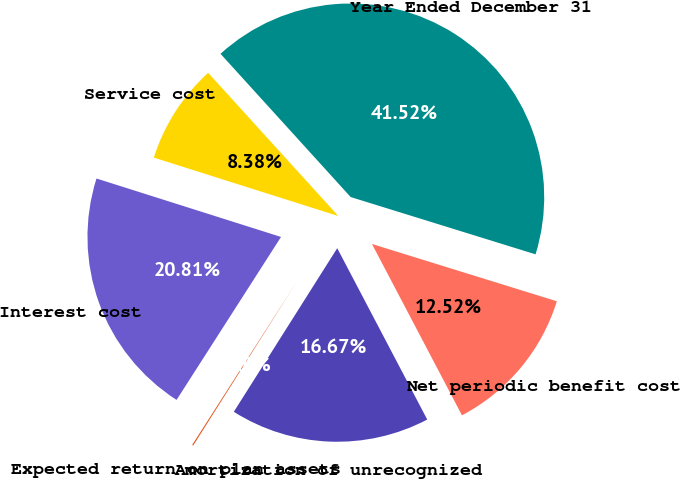Convert chart to OTSL. <chart><loc_0><loc_0><loc_500><loc_500><pie_chart><fcel>Year Ended December 31<fcel>Service cost<fcel>Interest cost<fcel>Expected return on plan assets<fcel>Amortization of unrecognized<fcel>Net periodic benefit cost<nl><fcel>41.52%<fcel>8.38%<fcel>20.81%<fcel>0.1%<fcel>16.67%<fcel>12.52%<nl></chart> 